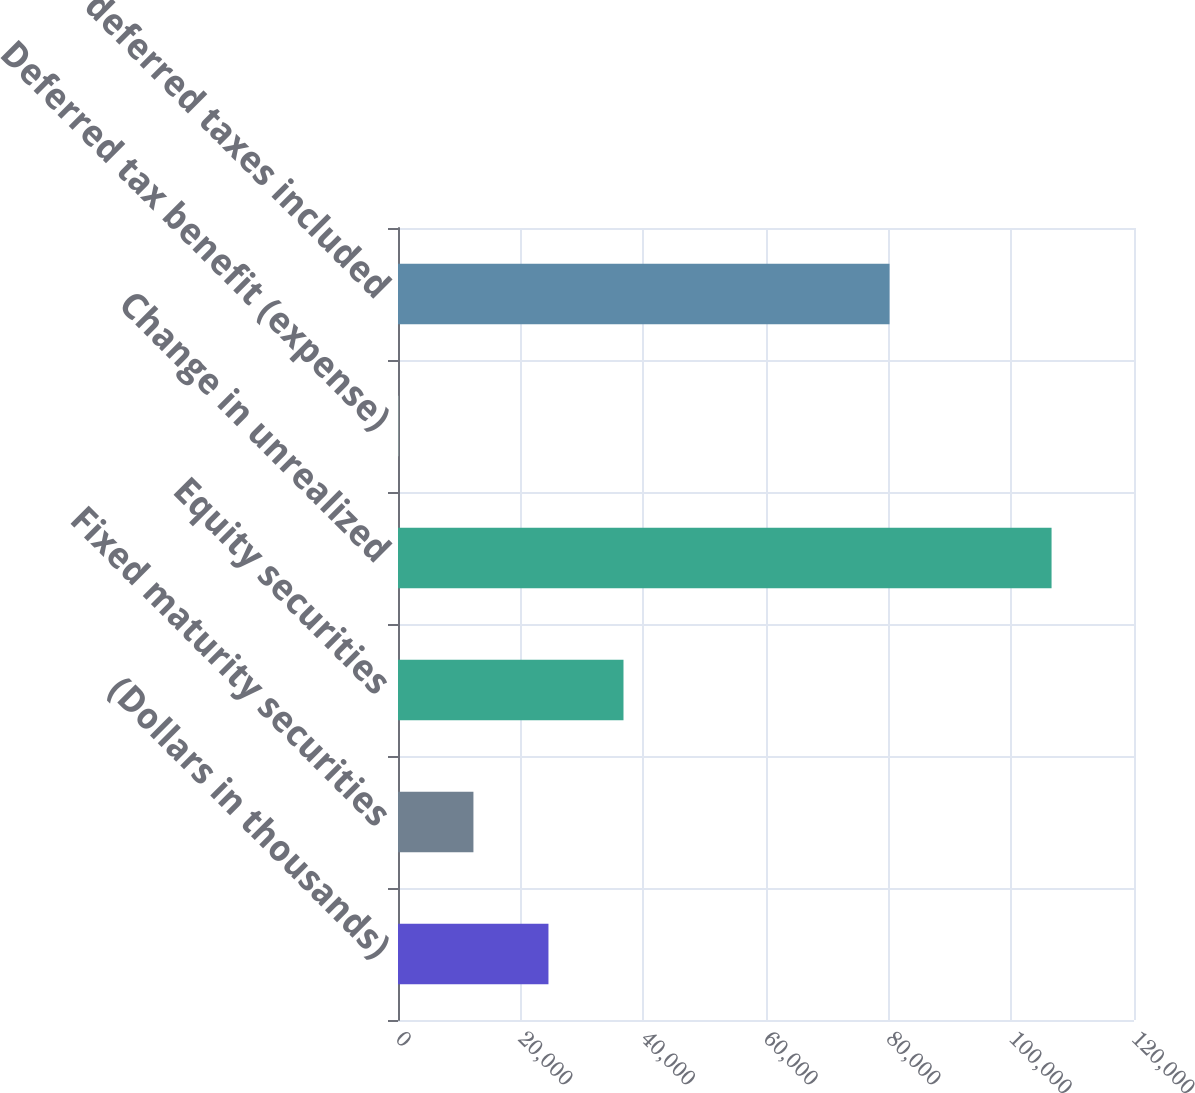Convert chart. <chart><loc_0><loc_0><loc_500><loc_500><bar_chart><fcel>(Dollars in thousands)<fcel>Fixed maturity securities<fcel>Equity securities<fcel>Change in unrealized<fcel>Deferred tax benefit (expense)<fcel>net of deferred taxes included<nl><fcel>24531.4<fcel>12298.7<fcel>36764.1<fcel>106559<fcel>66<fcel>80141<nl></chart> 